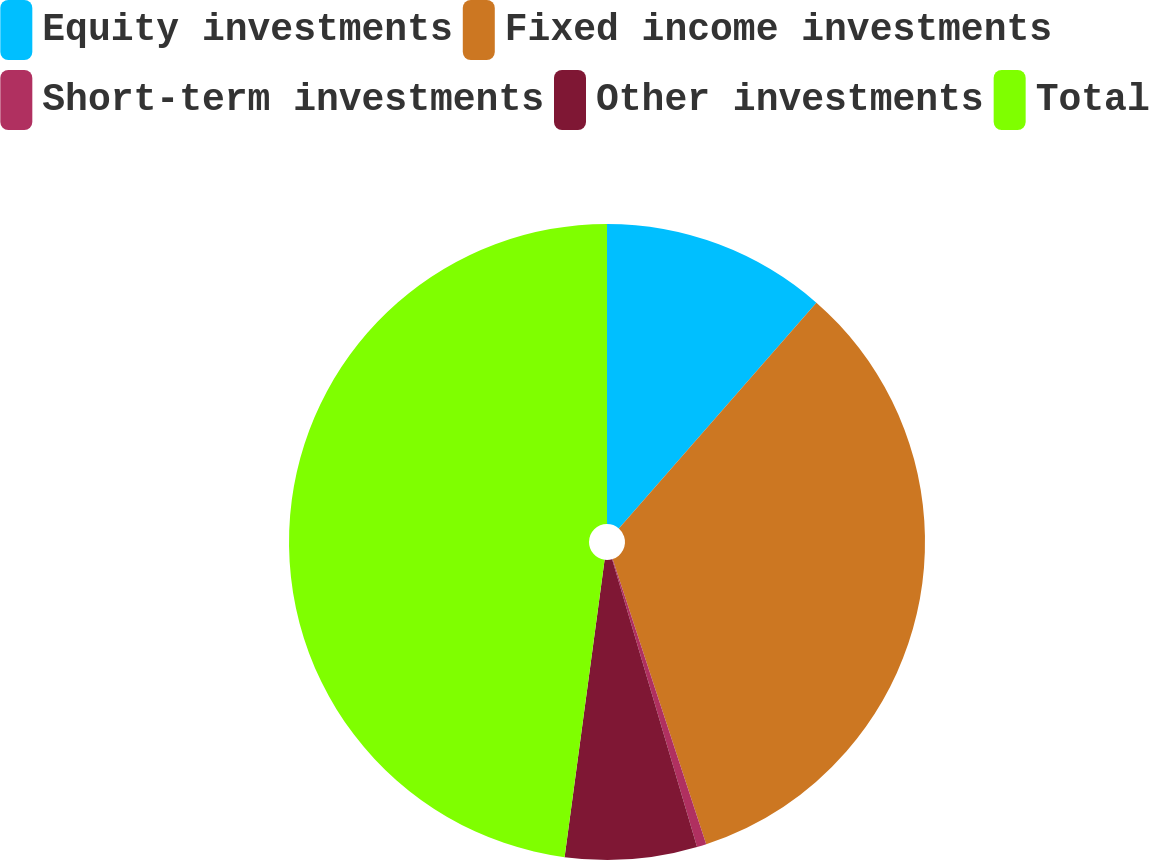Convert chart. <chart><loc_0><loc_0><loc_500><loc_500><pie_chart><fcel>Equity investments<fcel>Fixed income investments<fcel>Short-term investments<fcel>Other investments<fcel>Total<nl><fcel>11.44%<fcel>33.51%<fcel>0.48%<fcel>6.7%<fcel>47.87%<nl></chart> 